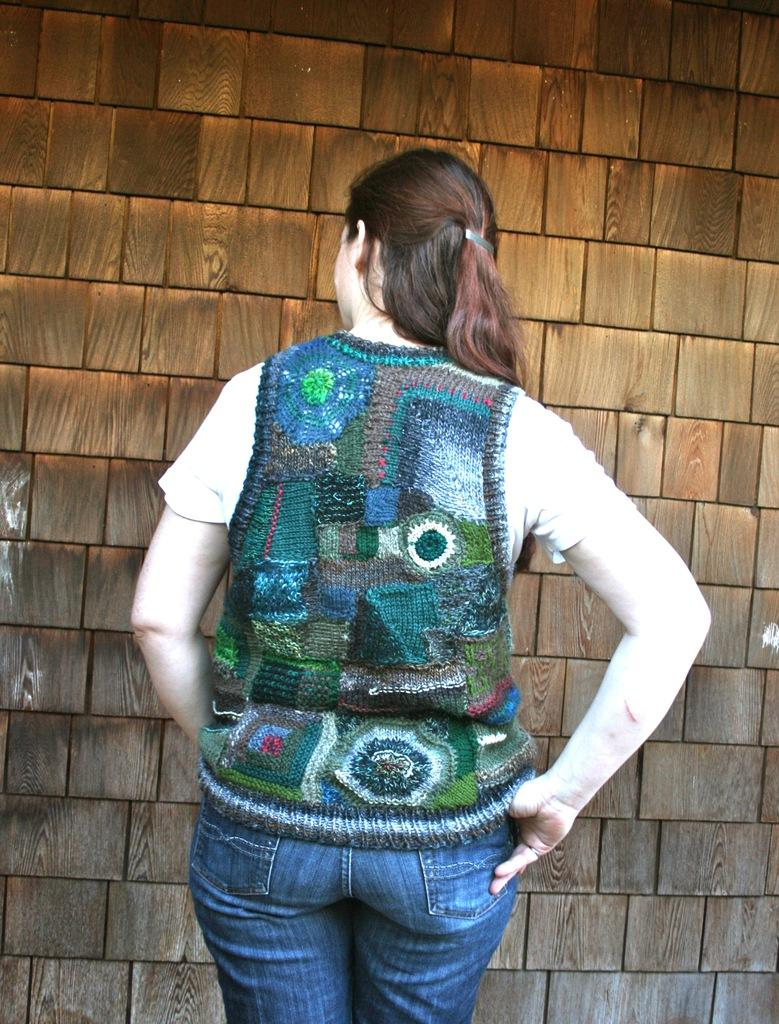Who is the main subject in the picture? There is a woman in the picture. What direction is the woman facing? The woman is facing backwards. What type of clothing is the woman wearing? The woman is wearing a jacket and blue jeans. What can be seen on the wall in the picture? There is a wall with wooden tiles in the picture. What type of quiver is the woman holding in the picture? There is no quiver present in the picture; the woman is not holding any such object. Can you describe the woman's ability to turn in the image? The image does not show the woman turning or provide any information about her ability to turn. 